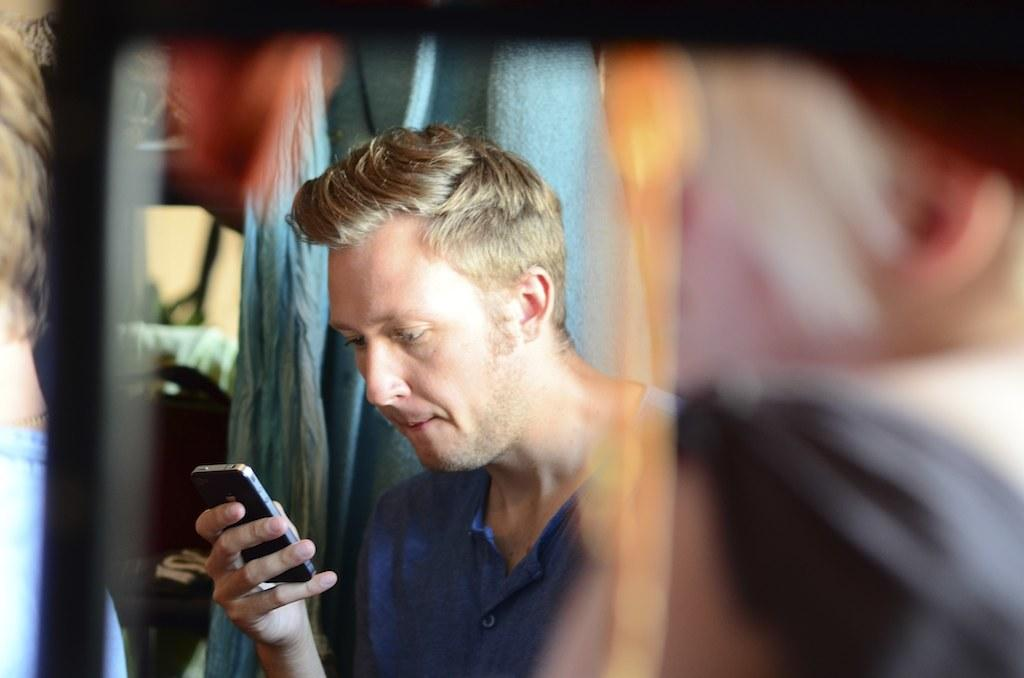What is present in the image? There is a man in the image. Can you describe what the man is wearing? The man is wearing a blue dress. What object is the man holding in the image? The man is holding a phone. How many ants can be seen crawling on the man's dress in the image? There are no ants visible on the man's dress in the image. What is the mass of the phone the man is holding in the image? The mass of the phone cannot be determined from the image alone. 